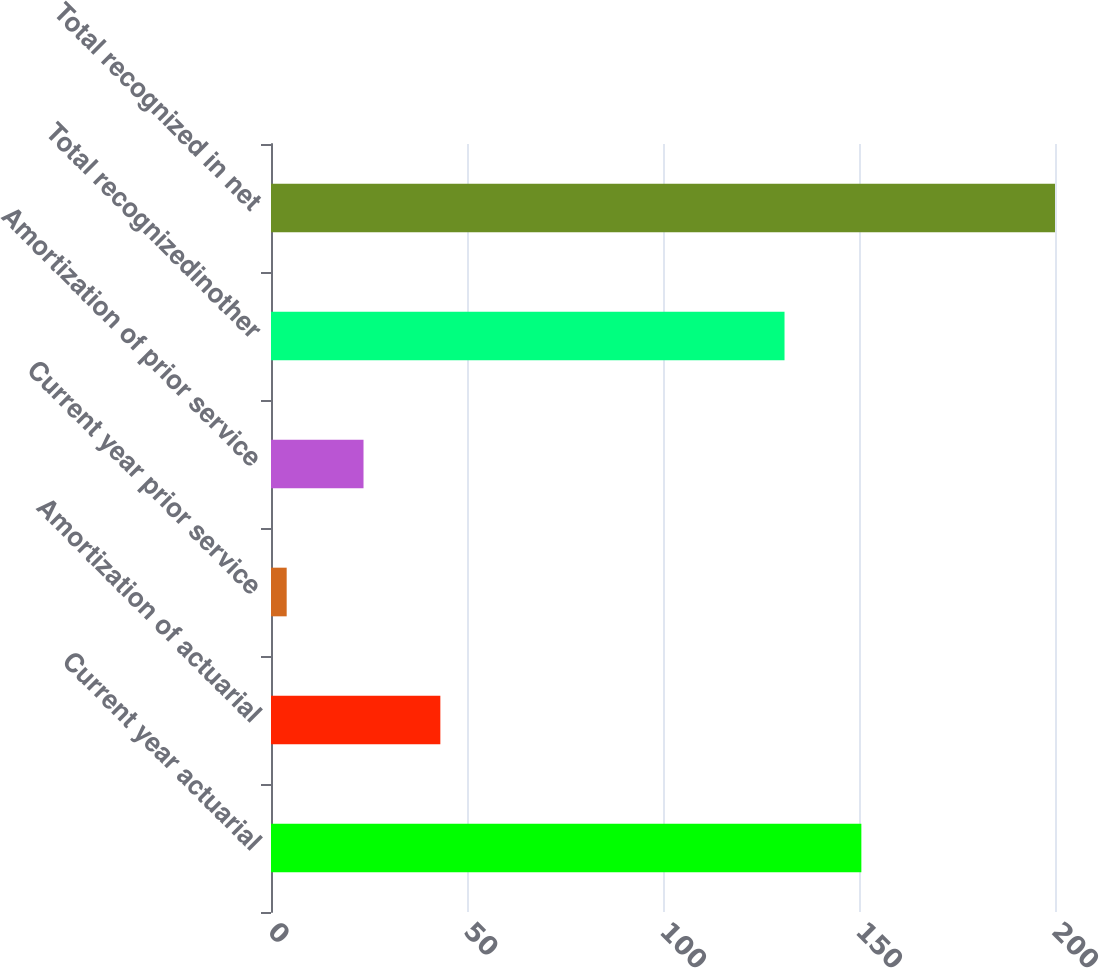<chart> <loc_0><loc_0><loc_500><loc_500><bar_chart><fcel>Current year actuarial<fcel>Amortization of actuarial<fcel>Current year prior service<fcel>Amortization of prior service<fcel>Total recognizedinother<fcel>Total recognized in net<nl><fcel>150.6<fcel>43.2<fcel>4<fcel>23.6<fcel>131<fcel>200<nl></chart> 